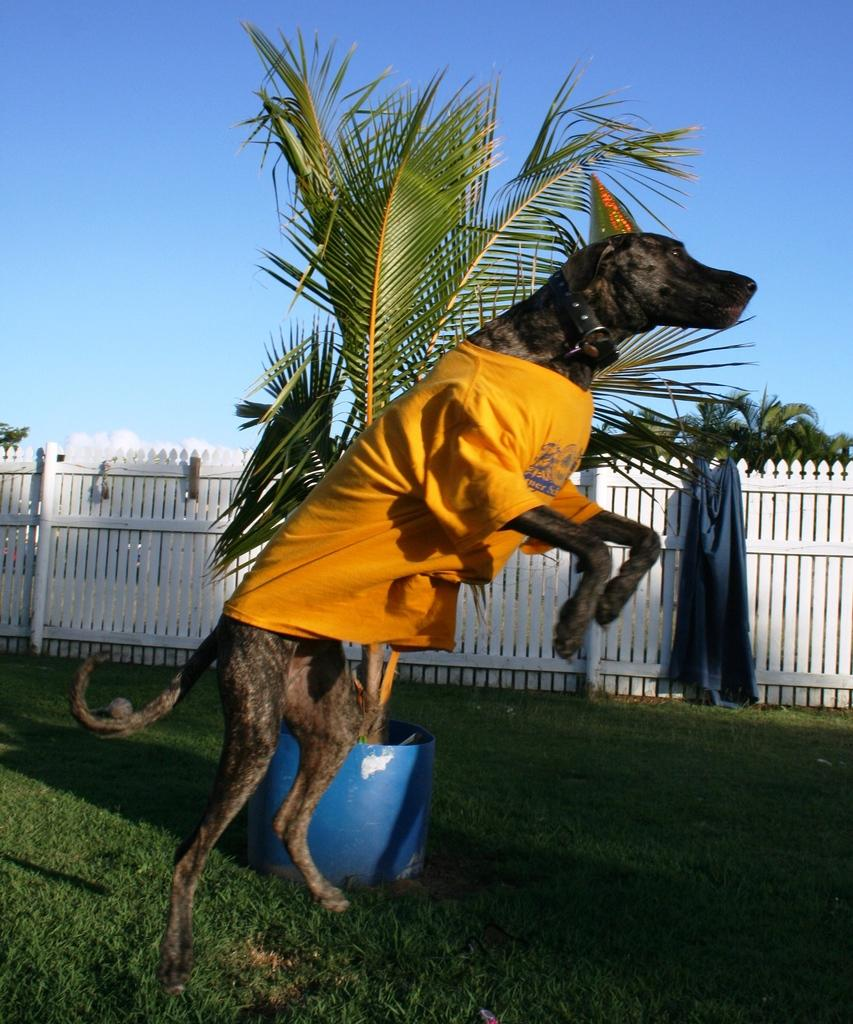What is the dog in the image wearing? The dog is wearing a T-shirt in the image. Where is the dog located? The dog is on a grassland in the image. What can be seen in the background of the image? There is a plant, a wooden railing, a cloth, trees, and the sky visible in the background of the image. What type of toys does the dog's daughter play with in the image? There is no mention of a daughter or toys in the image; it features a dog wearing a T-shirt on a grassland with a background that includes a plant, a wooden railing, a cloth, trees, and the sky. 